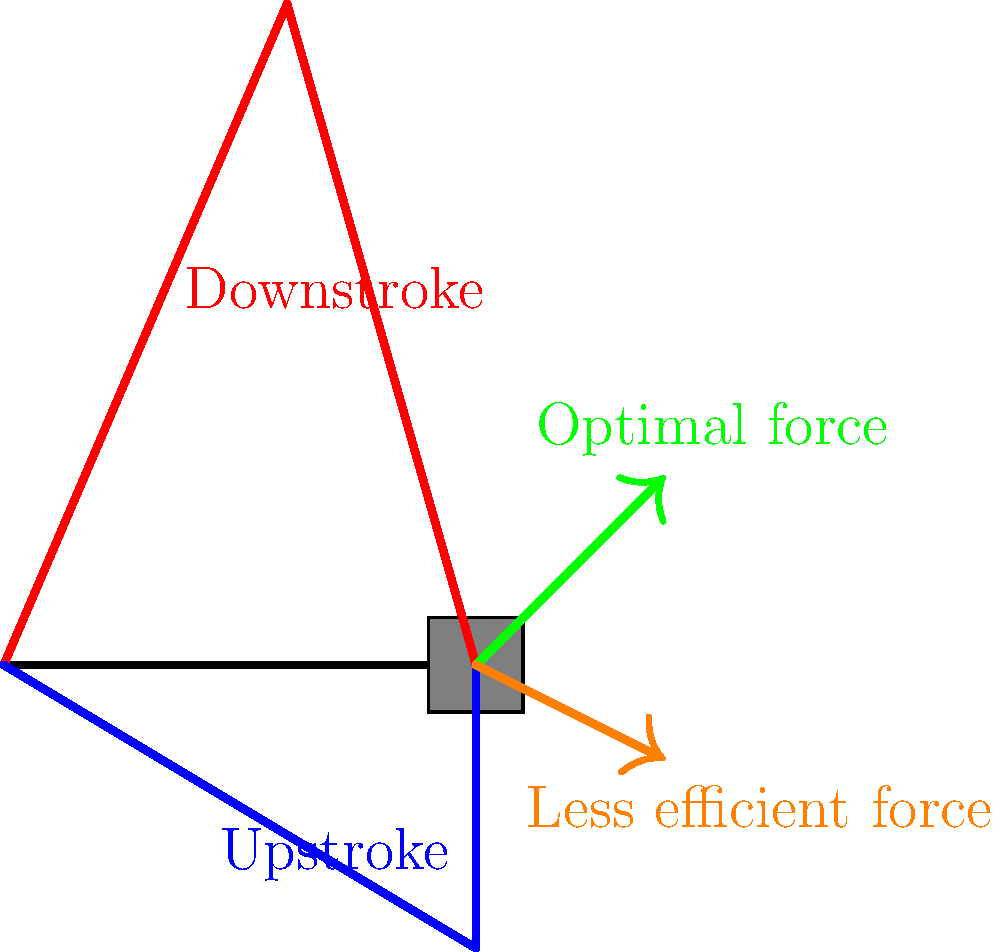In bicycle pedaling, which leg position typically allows for the most efficient force application, and why is this the case from a biomechanical perspective? To understand the biomechanical efficiency of bicycle pedaling techniques, we need to consider the following factors:

1. Leg position: The diagram shows two main positions - downstroke (red) and upstroke (blue).

2. Force application: The green arrow represents the optimal force direction, while the orange arrow shows a less efficient force application.

3. Leverage: The bicycle crank acts as a lever, with the pedal as the effort point and the crank center as the fulcrum.

4. Muscle engagement: Different leg positions engage different muscle groups.

5. Gravity: The downward force of gravity aids the downstroke but opposes the upstroke.

Analyzing these factors:

a) The downstroke position (red) allows for more direct force application in the direction of pedal movement. This is represented by the green arrow, which is more tangential to the pedal's circular path.

b) During the downstroke, larger muscle groups (quadriceps, glutes) are engaged, providing more power.

c) The downstroke benefits from the added force of gravity working with the leg muscles.

d) The upstroke position (blue) is less efficient because:
   - It works against gravity
   - It engages smaller muscle groups (hamstrings, calves)
   - The force application is less aligned with the pedal's movement (orange arrow)

e) The most efficient pedaling technique involves applying force throughout the entire pedal stroke, but with emphasis on the downstroke.

Therefore, from a biomechanical perspective, the downstroke position (represented in red) typically allows for the most efficient force application due to optimal muscle engagement, leverage, and alignment with gravity.
Answer: Downstroke position 